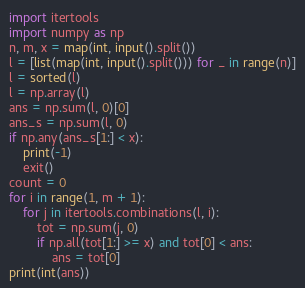<code> <loc_0><loc_0><loc_500><loc_500><_Python_>import itertools
import numpy as np
n, m, x = map(int, input().split())
l = [list(map(int, input().split())) for _ in range(n)]
l = sorted(l)
l = np.array(l)
ans = np.sum(l, 0)[0]
ans_s = np.sum(l, 0)
if np.any(ans_s[1:] < x):
    print(-1)
    exit()
count = 0
for i in range(1, m + 1):
    for j in itertools.combinations(l, i):
        tot = np.sum(j, 0)
        if np.all(tot[1:] >= x) and tot[0] < ans:
            ans = tot[0]
print(int(ans))
</code> 